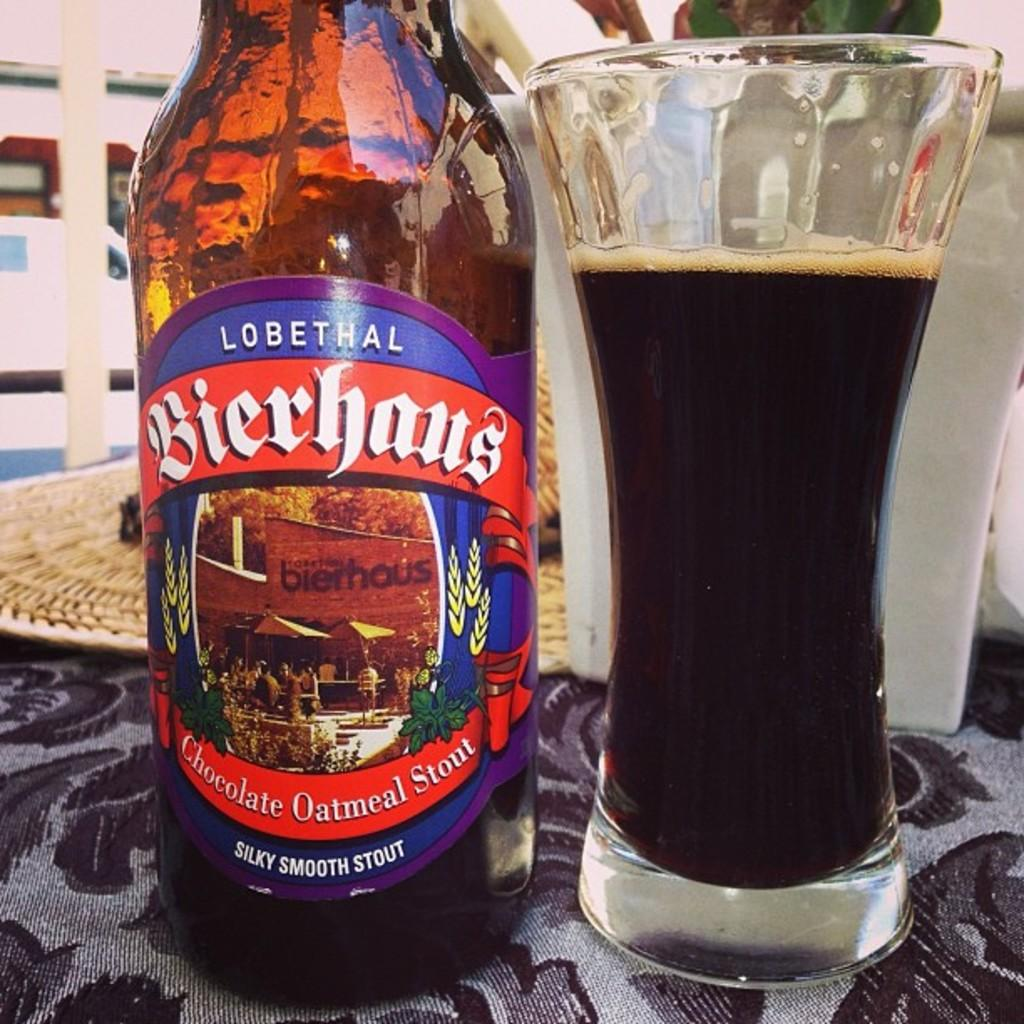<image>
Provide a brief description of the given image. the word oatmeal is on a beer bottle 